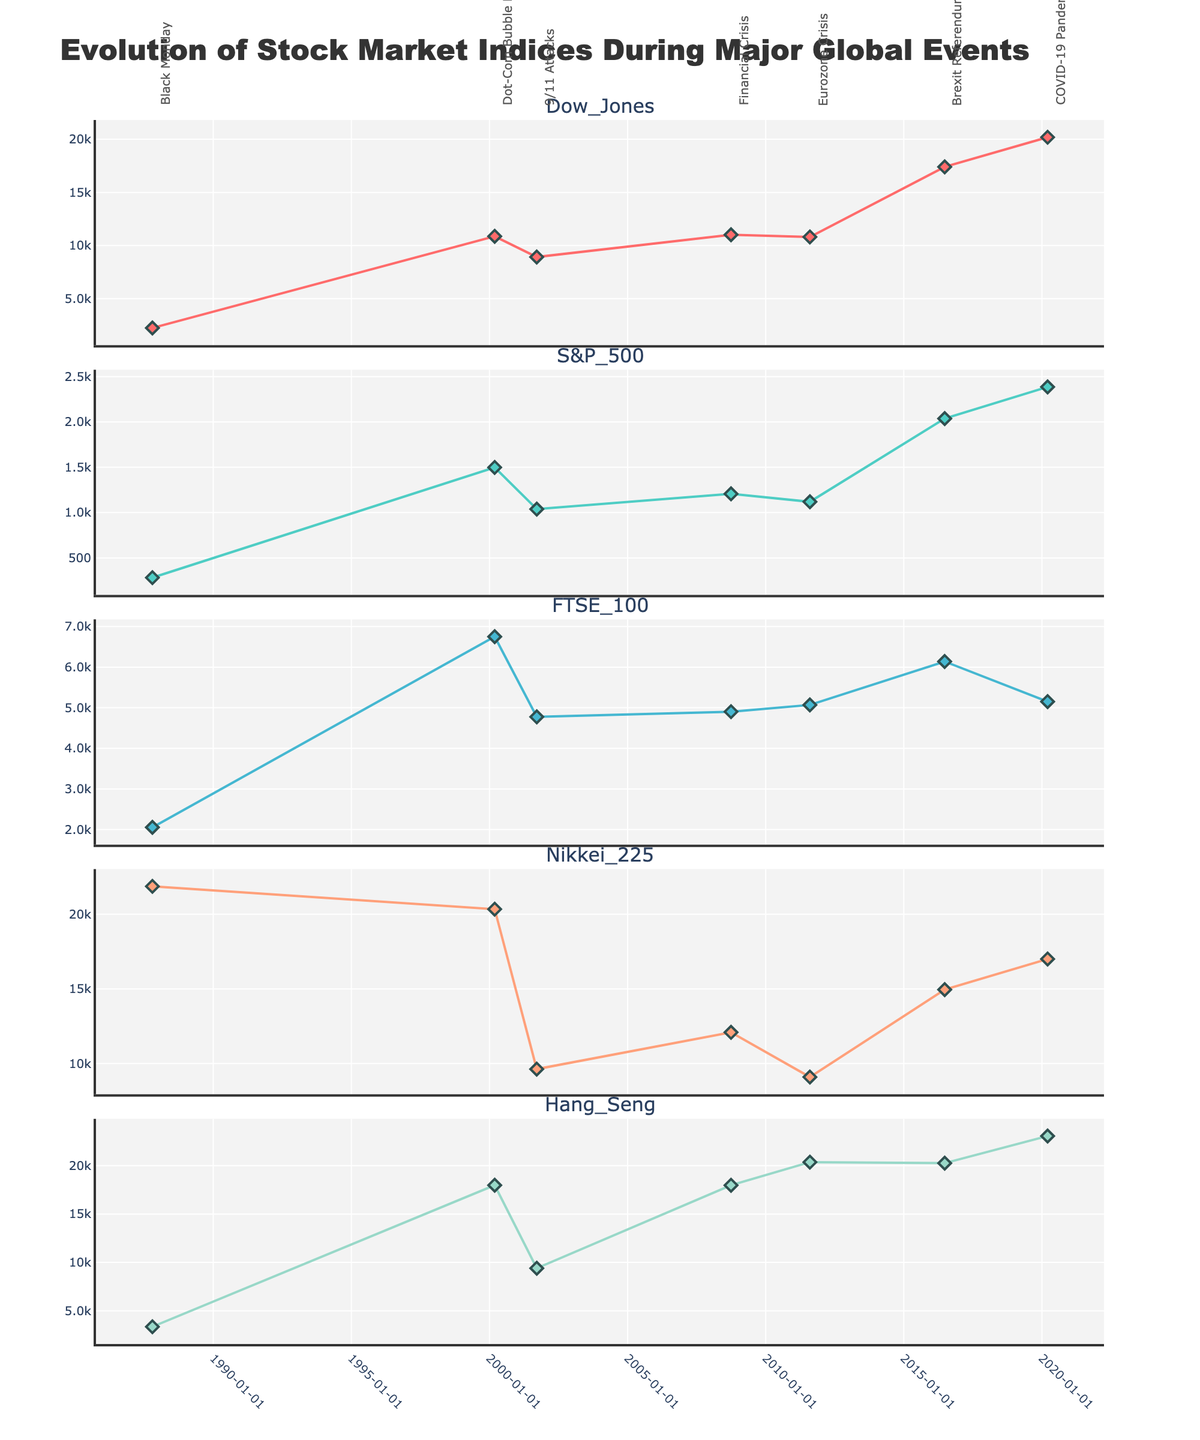What is the title of the plot? The title is located at the top of the plot and gives a brief description of the content being visualized.
Answer: Evolution of Stock Market Indices During Major Global Events How many stock indices are plotted in the figure? Each subplot represents a different stock index, and there are a total of these plotted in the figure. Count the number of subplot titles to get the exact number.
Answer: 5 Which event caused the largest drop in the Dow Jones index? By examining the data points for the Dow Jones index across different events, we can identify the event with the lowest value. The sharpest decline is evident around the date of Black Monday.
Answer: Black Monday What is the highest value recorded for the S&P 500 index among the events? Find the highest y-value among the data points for the S&P 500 index across all the events in the plot.
Answer: 2386.13 Which stock index has the highest value on Black Monday? Compare the values of all stock indices on the date of Black Monday and identify the one with the highest value.
Answer: Nikkei 225 How did the FTSE 100 index change from the Financial Crisis to the COVID-19 Pandemic? Look at the y-values of the FTSE 100 index during the Financial Crisis and the COVID-19 Pandemic, and compute the difference. Note that the FTSE 100 value during the Financial Crisis is 4902.45 and during the COVID-19 Pandemic is 5151.08. Subtract the former from the latter.
Answer: Increased by 248.63 Which index had the smallest value during the Eurozone Crisis? Examine the values for all indices during the Eurozone Crisis and identify the one with the smallest y-value.
Answer: S&P 500 On the Brexit Referendum, which two indices have values closer to each other? Look at the values of all indices on the date of the Brexit Referendum, compare them, and determine which two are the closest in value.
Answer: Nikkei 225 and Hang Seng What is the average value of the Nikkei 225 index across all events? Add up all the values of the Nikkei 225 index for each event and then divide by the number of events. The values are 21865.00, 20337.32, 9629.27, 12090.59, 9097.56, 14952.02, and 17002.04.
Answer: 14953.11 Which stock index shows the widest range of fluctuation across the events? Calculate the range (difference between the highest and lowest values) for each stock index and identify the one with the widest range.
Answer: Nikkei 225 